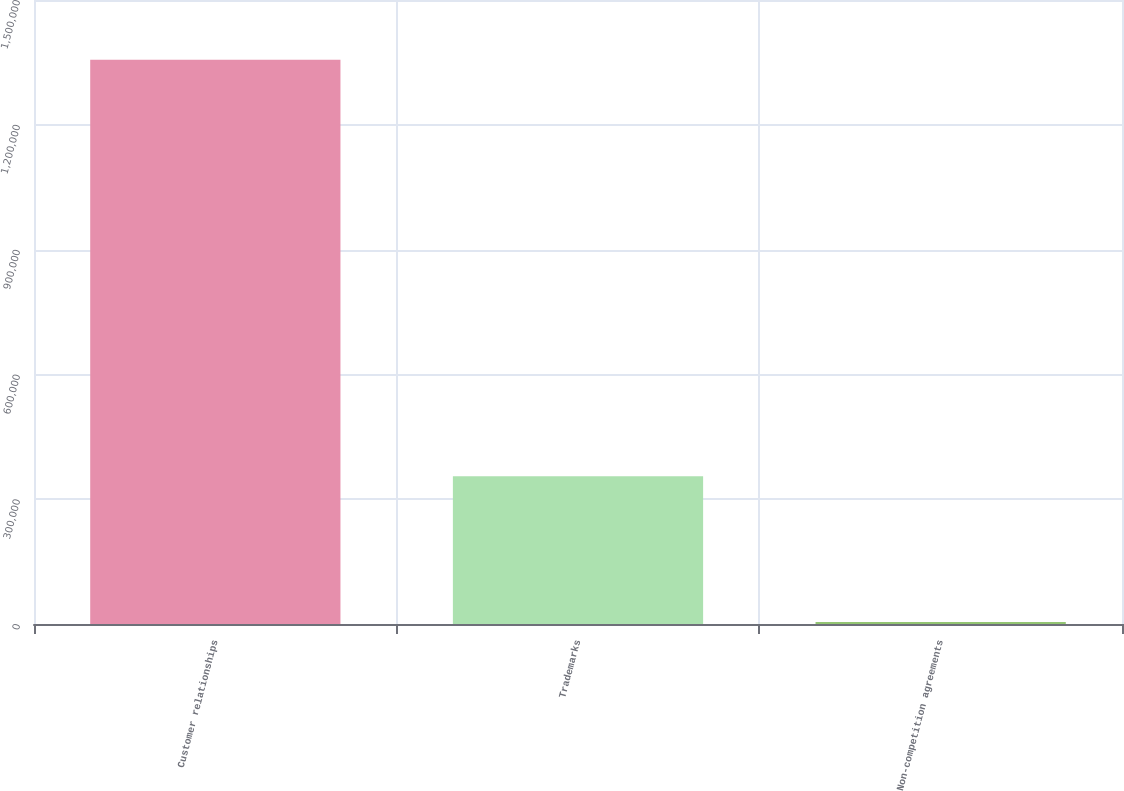Convert chart. <chart><loc_0><loc_0><loc_500><loc_500><bar_chart><fcel>Customer relationships<fcel>Trademarks<fcel>Non-competition agreements<nl><fcel>1.35635e+06<fcel>355117<fcel>5009<nl></chart> 